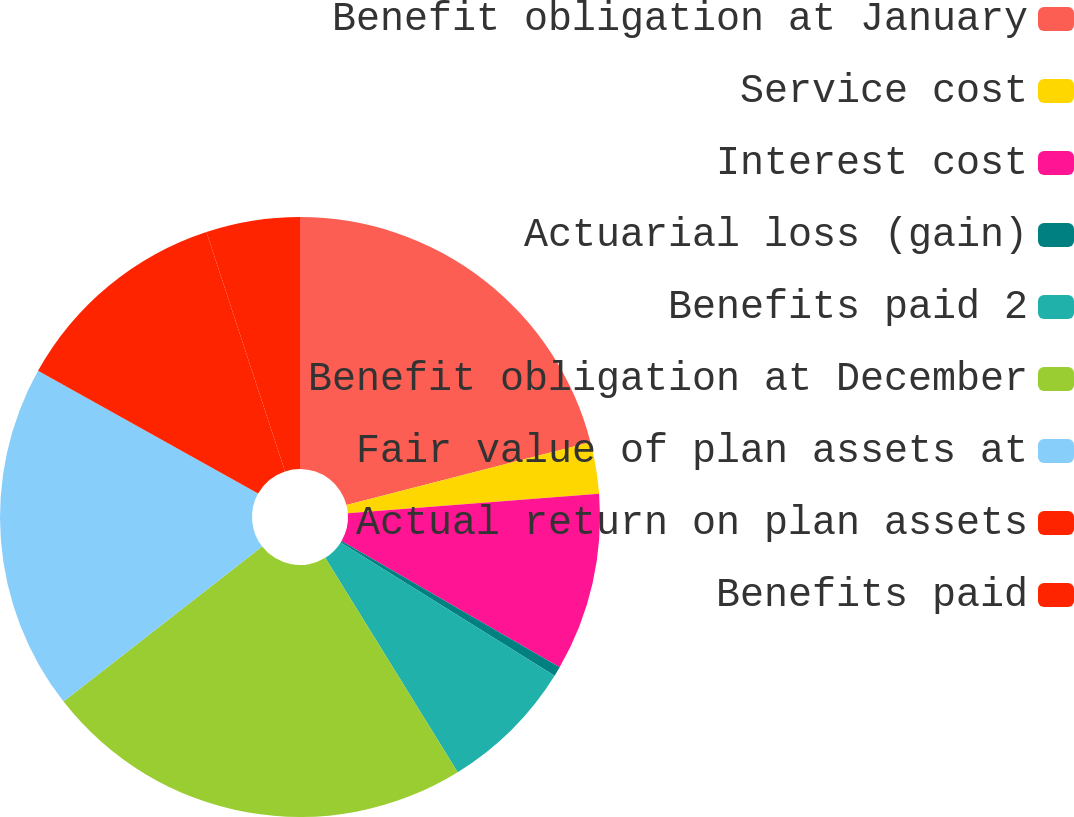<chart> <loc_0><loc_0><loc_500><loc_500><pie_chart><fcel>Benefit obligation at January<fcel>Service cost<fcel>Interest cost<fcel>Actuarial loss (gain)<fcel>Benefits paid 2<fcel>Benefit obligation at December<fcel>Fair value of plan assets at<fcel>Actual return on plan assets<fcel>Benefits paid<nl><fcel>20.99%<fcel>2.78%<fcel>9.58%<fcel>0.52%<fcel>7.32%<fcel>23.26%<fcel>18.65%<fcel>11.85%<fcel>5.05%<nl></chart> 